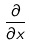<formula> <loc_0><loc_0><loc_500><loc_500>\frac { \partial } { \partial x }</formula> 